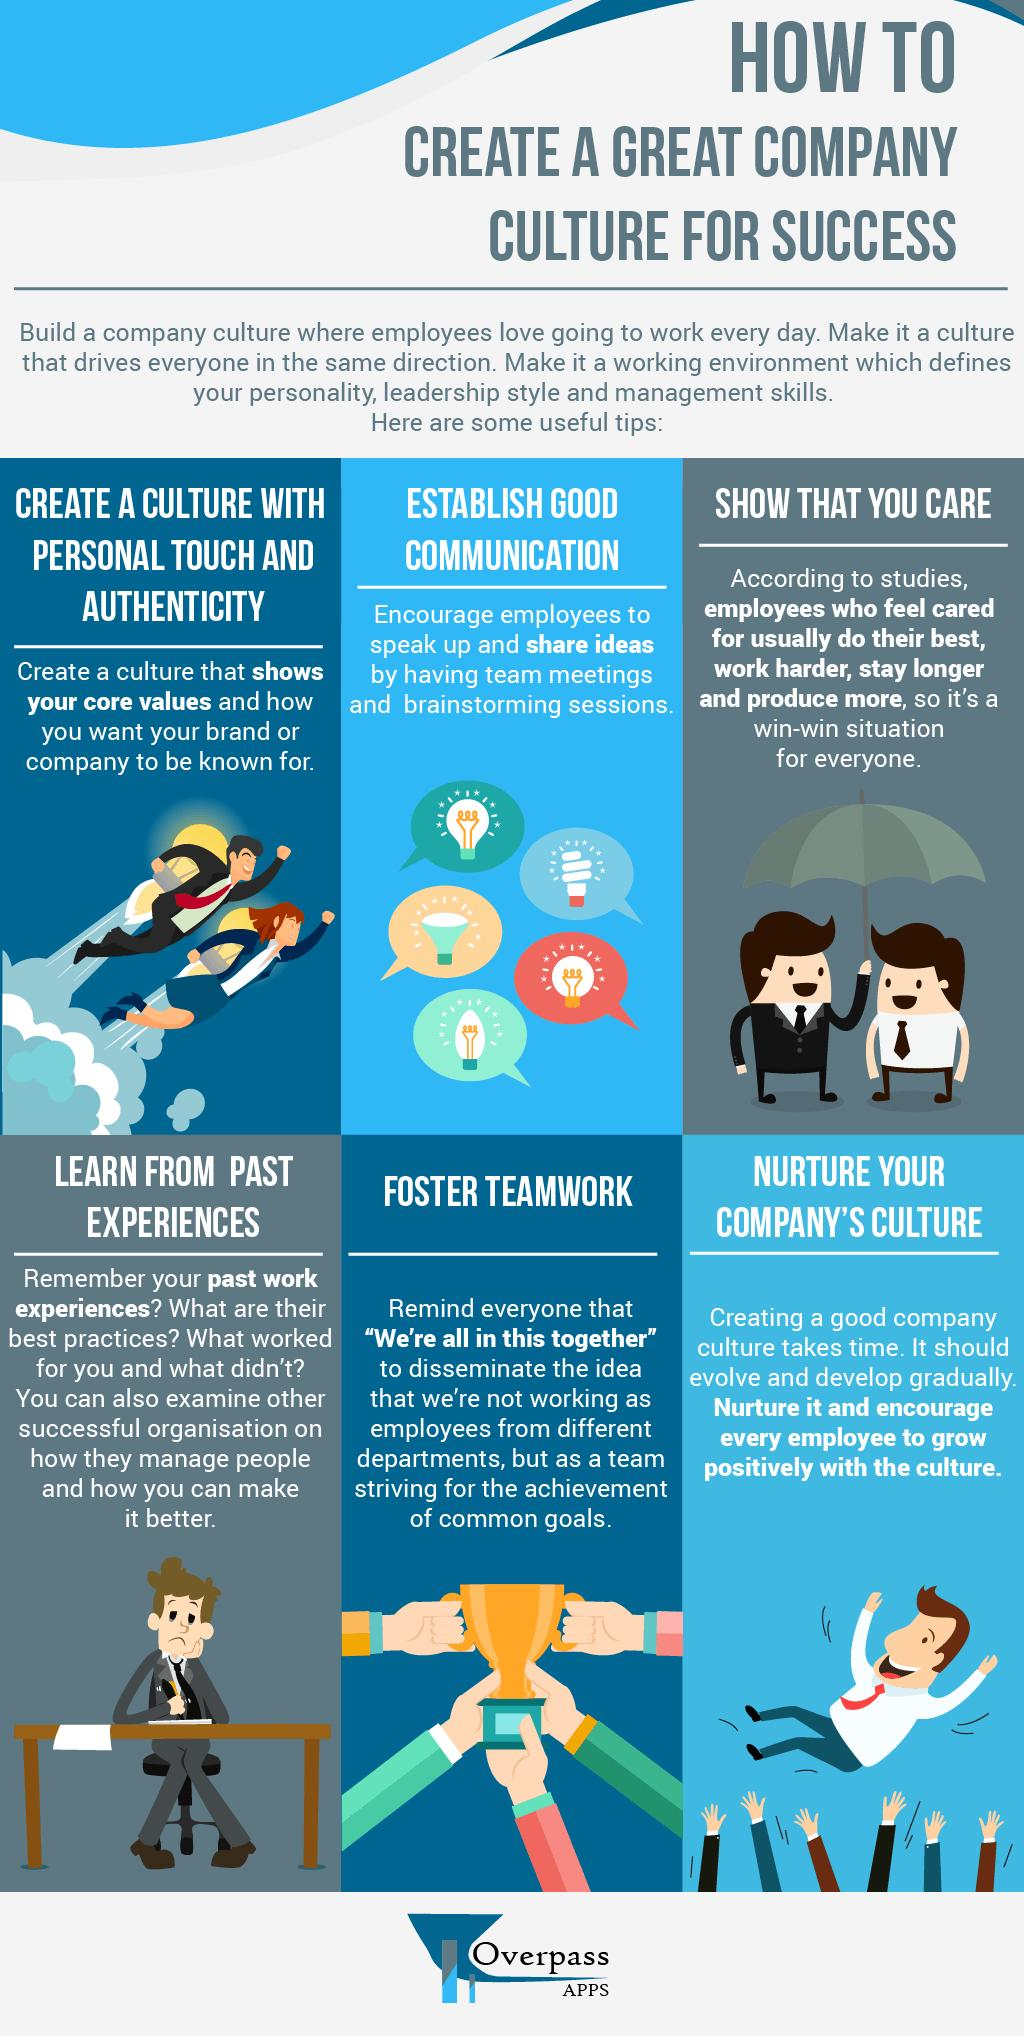Outline some significant characteristics in this image. To create a thriving and successful company culture, fostering teamwork is a crucial step. To foster a thriving company culture, it is crucial to nurture and maintain it consistently. Creating a great company culture for success requires the third step, which is demonstrating that you genuinely care about your employees and their well-being. 